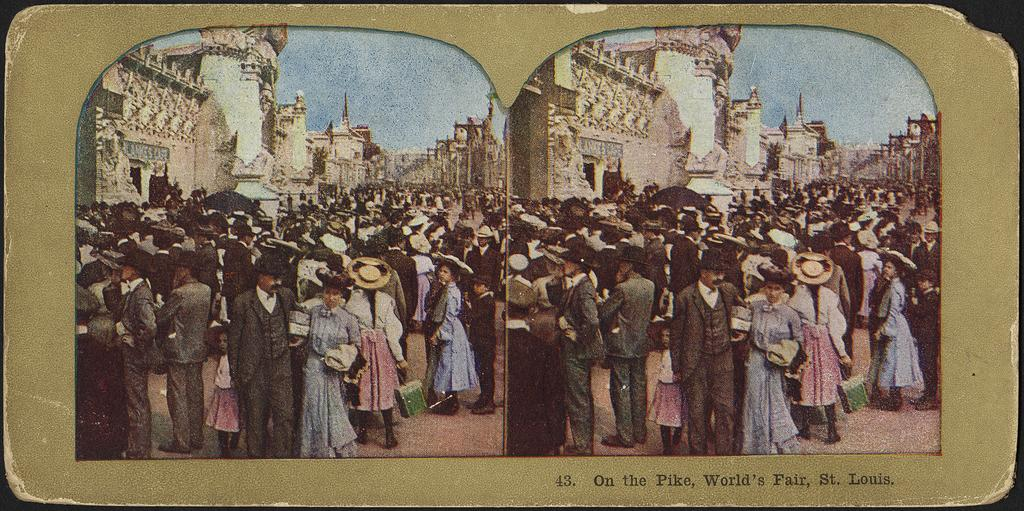<image>
Provide a brief description of the given image. Two photos of a large crowd of people at the World's Fair. 